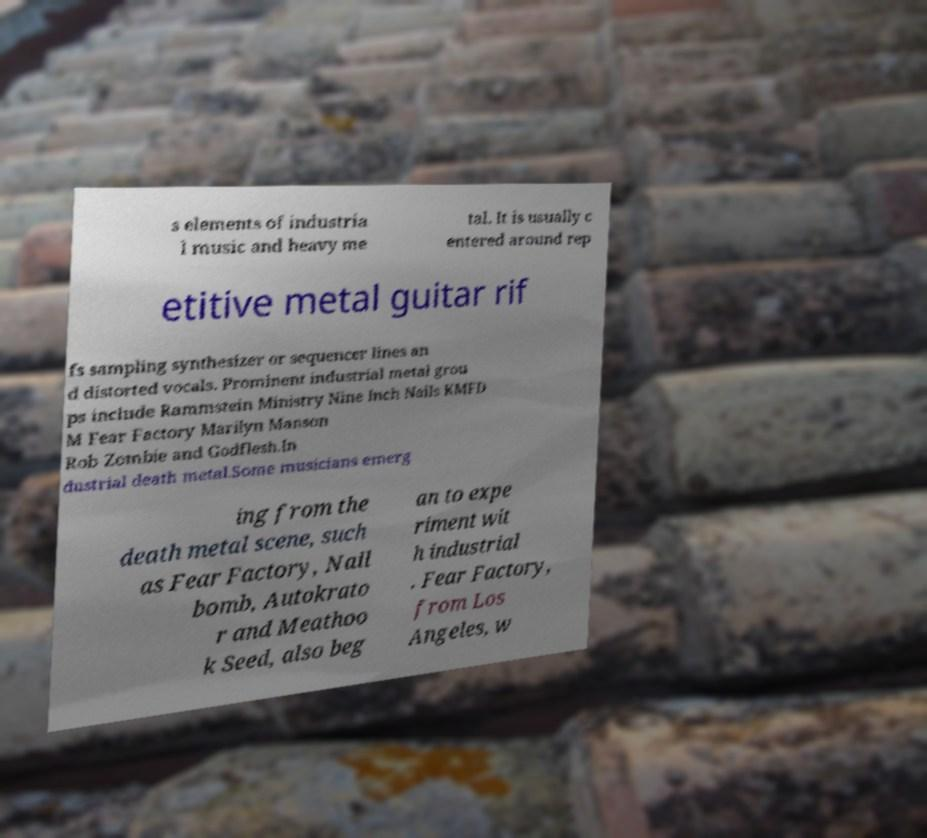Please identify and transcribe the text found in this image. s elements of industria l music and heavy me tal. It is usually c entered around rep etitive metal guitar rif fs sampling synthesizer or sequencer lines an d distorted vocals. Prominent industrial metal grou ps include Rammstein Ministry Nine Inch Nails KMFD M Fear Factory Marilyn Manson Rob Zombie and Godflesh.In dustrial death metal.Some musicians emerg ing from the death metal scene, such as Fear Factory, Nail bomb, Autokrato r and Meathoo k Seed, also beg an to expe riment wit h industrial . Fear Factory, from Los Angeles, w 